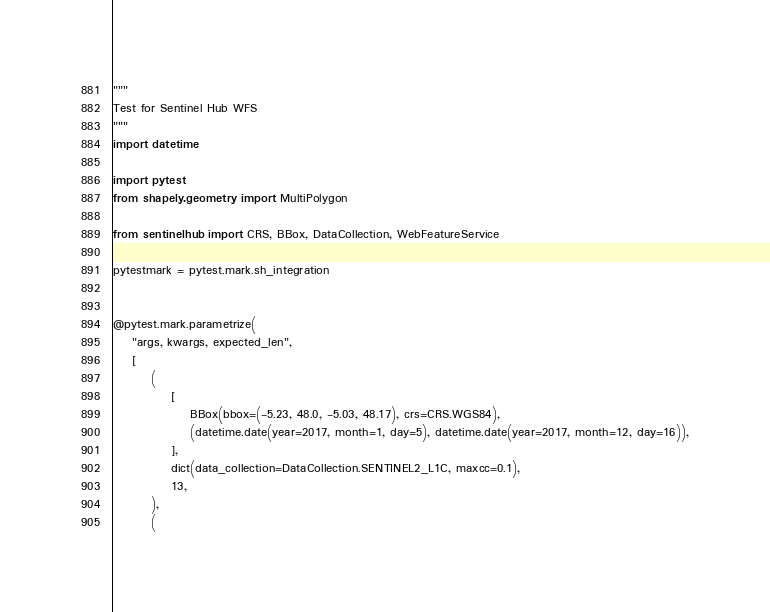Convert code to text. <code><loc_0><loc_0><loc_500><loc_500><_Python_>"""
Test for Sentinel Hub WFS
"""
import datetime

import pytest
from shapely.geometry import MultiPolygon

from sentinelhub import CRS, BBox, DataCollection, WebFeatureService

pytestmark = pytest.mark.sh_integration


@pytest.mark.parametrize(
    "args, kwargs, expected_len",
    [
        (
            [
                BBox(bbox=(-5.23, 48.0, -5.03, 48.17), crs=CRS.WGS84),
                (datetime.date(year=2017, month=1, day=5), datetime.date(year=2017, month=12, day=16)),
            ],
            dict(data_collection=DataCollection.SENTINEL2_L1C, maxcc=0.1),
            13,
        ),
        (</code> 